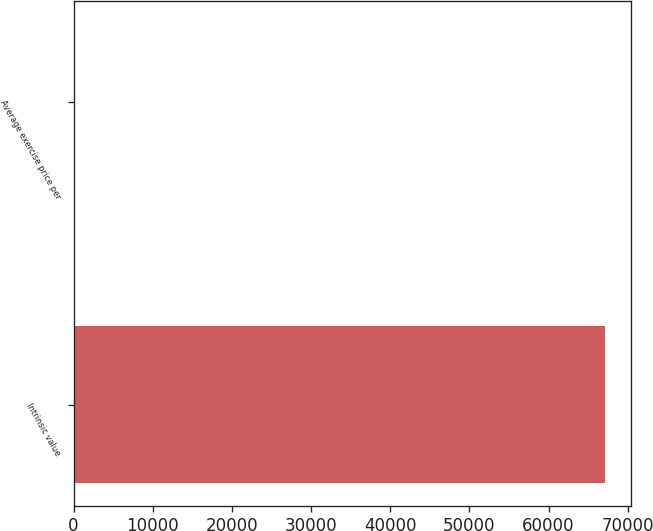Convert chart to OTSL. <chart><loc_0><loc_0><loc_500><loc_500><bar_chart><fcel>Intrinsic value<fcel>Average exercise price per<nl><fcel>67089<fcel>34.56<nl></chart> 